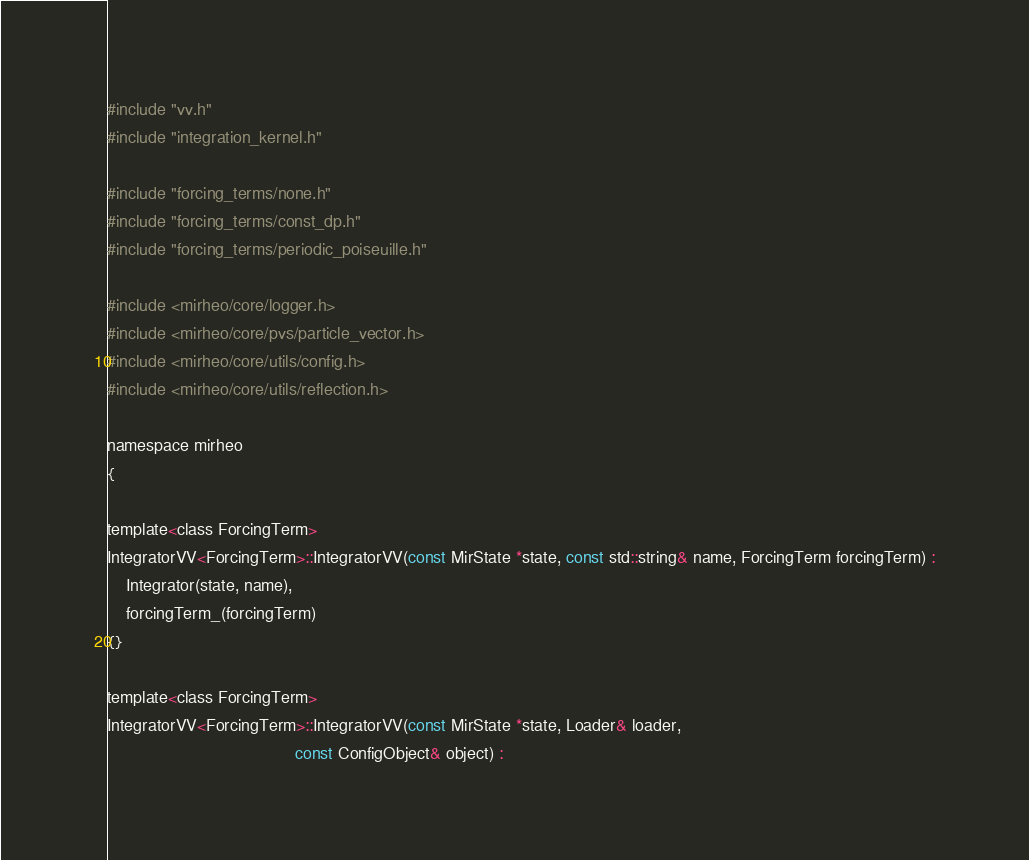<code> <loc_0><loc_0><loc_500><loc_500><_Cuda_>#include "vv.h"
#include "integration_kernel.h"

#include "forcing_terms/none.h"
#include "forcing_terms/const_dp.h"
#include "forcing_terms/periodic_poiseuille.h"

#include <mirheo/core/logger.h>
#include <mirheo/core/pvs/particle_vector.h>
#include <mirheo/core/utils/config.h>
#include <mirheo/core/utils/reflection.h>

namespace mirheo
{

template<class ForcingTerm>
IntegratorVV<ForcingTerm>::IntegratorVV(const MirState *state, const std::string& name, ForcingTerm forcingTerm) :
    Integrator(state, name),
    forcingTerm_(forcingTerm)
{}

template<class ForcingTerm>
IntegratorVV<ForcingTerm>::IntegratorVV(const MirState *state, Loader& loader,
                                        const ConfigObject& object) :</code> 